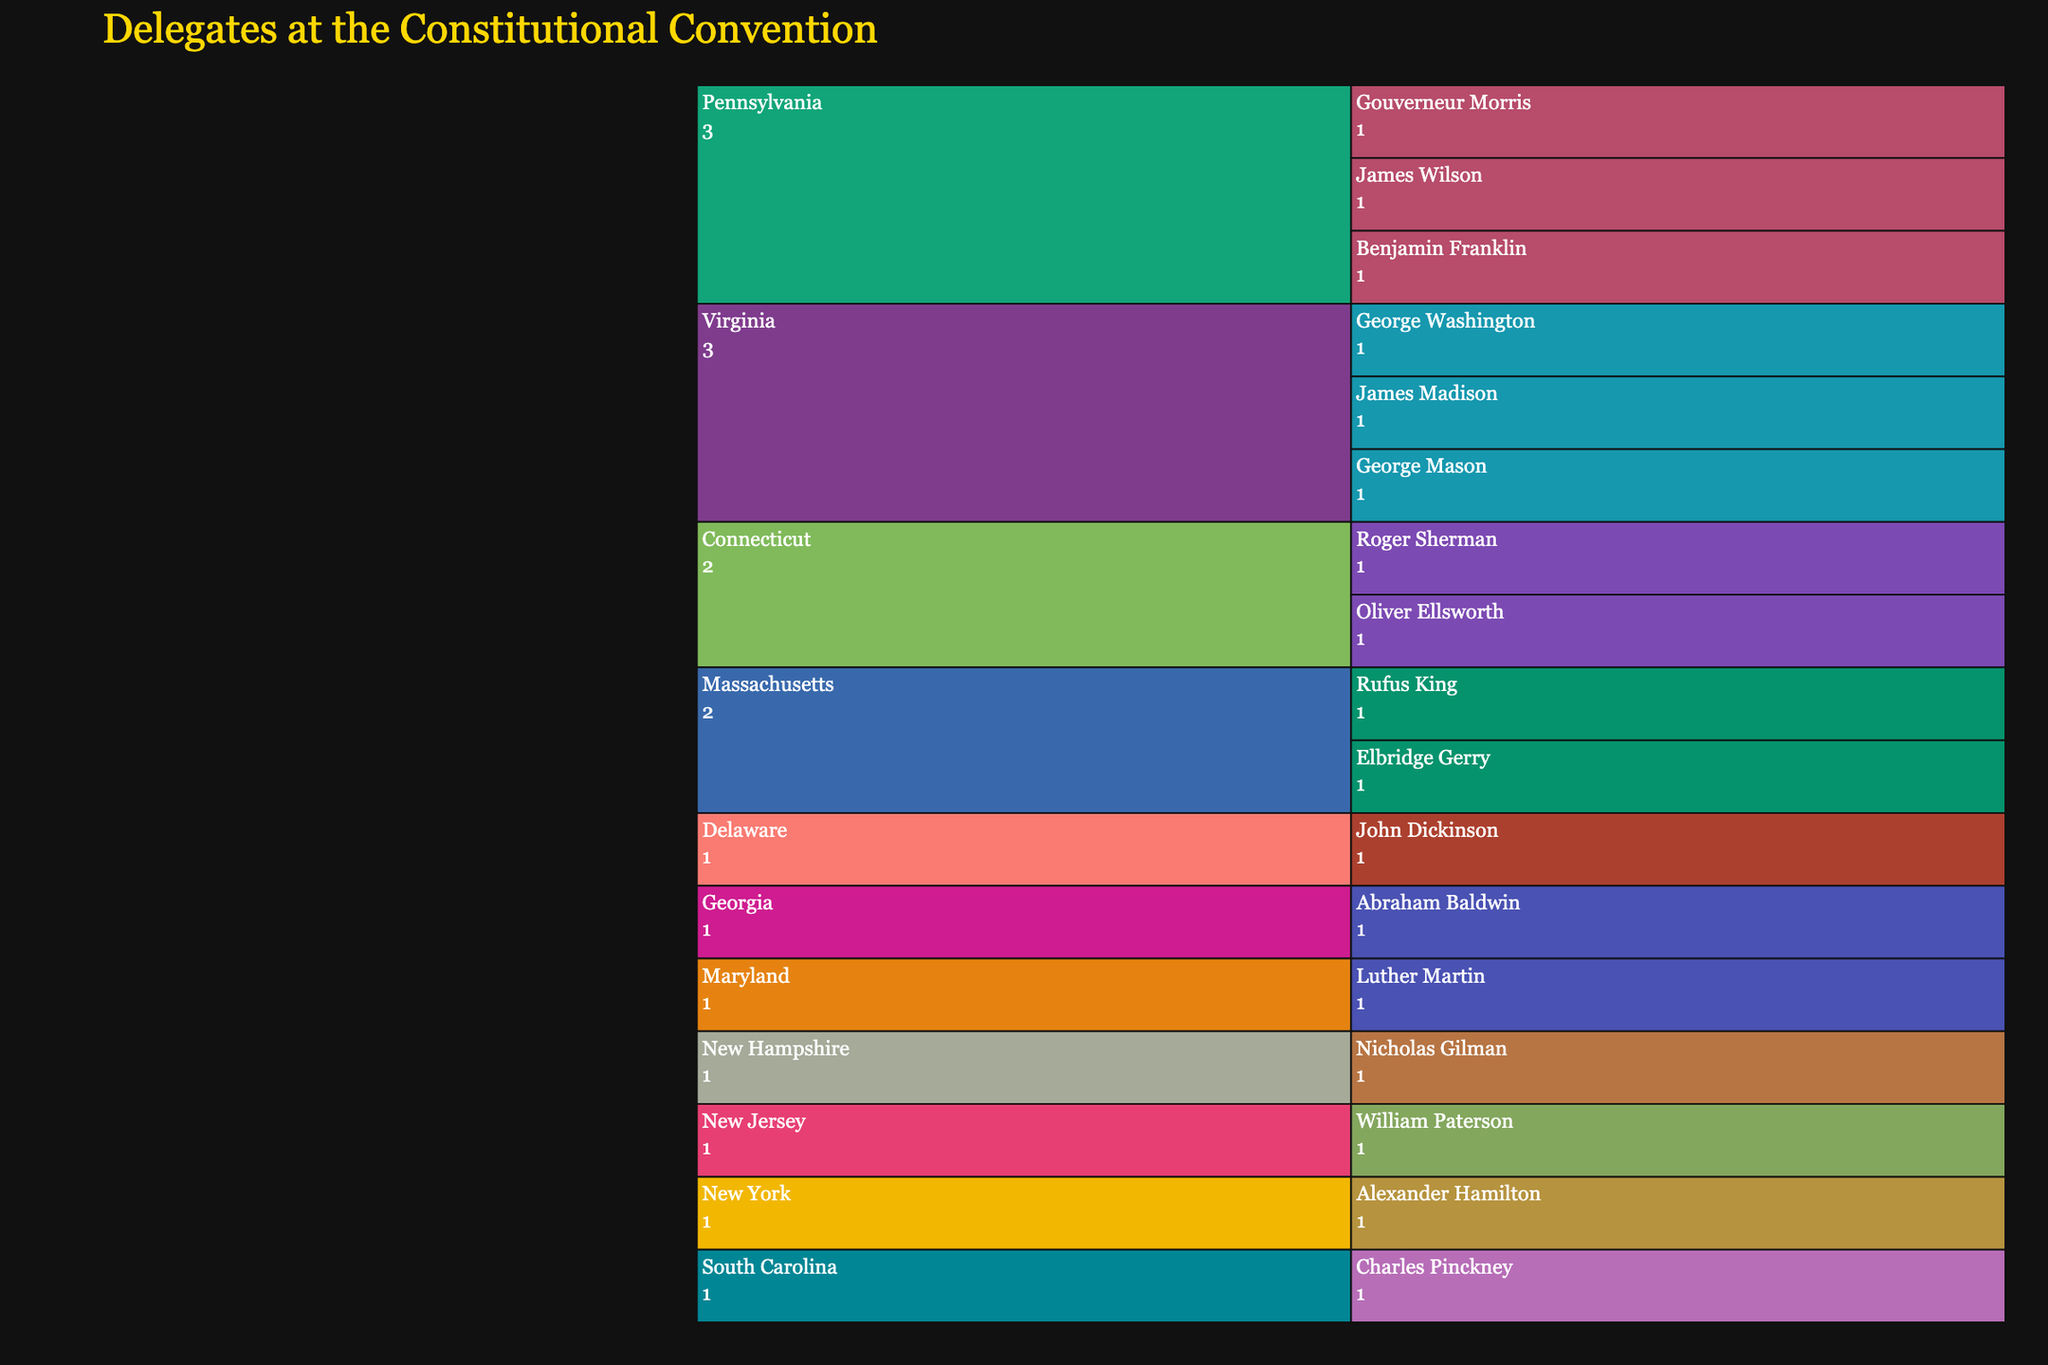What is the title of the icicle chart? The title is typically positioned at the top of the chart. It summarizes what the visualization is about, making it easier to understand the content at a glance.
Answer: Delegates at the Constitutional Convention Which state has the highest number of delegates shown in the chart? By checking the chart, count the delegates under each state. The state with the most delegates has the highest number.
Answer: Virginia Who contributed to the 'Compromiser and Elder Statesman' role? Hover over the sections represented by delegates to see their contributions. The delegate that matches 'Compromiser and Elder Statesman' provides the answer.
Answer: Benjamin Franklin Which delegate from Virginia was the 'Advocate for Bill of Rights'? Navigate to the Virginia section, identify the delegates listed under Virginia, and check their contributions.
Answer: George Mason How many delegates in total are displayed on the chart? Count all the delegates listed under each state's section on the icicle chart.
Answer: 16 Which state has more delegates, Massachusetts or New York? Compare the number of delegates listed under Massachusetts and New York. Massachusetts has two delegates and New York has one.
Answer: Massachusetts What is the contribution of the delegate from New Jersey? Find the delegate listed under New Jersey and look at their contribution description.
Answer: Proposed New Jersey Plan Compare the contributions of delegates from Connecticut and summarize them. Look at the contributions listed for the delegates from Connecticut. Roger Sherman is known as the 'Architect of Great Compromise', and Oliver Ellsworth is a 'Contributor to Court System Design'. Summarize these contributions.
Answer: Great Compromise and Court System Design Which states have only one delegate at the Constitutional Convention? Look at each state section and check which ones have a single delegate listed. These states are New York, New Jersey, Maryland, South Carolina, Georgia, Delaware, and New Hampshire.
Answer: New York, New Jersey, Maryland, South Carolina, Georgia, Delaware, New Hampshire What unique elements did Charles Pinckney propose according to his contribution? Check Charles Pinckney's section under South Carolina and read the contribution description for any unique elements proposed.
Answer: Structural elements 